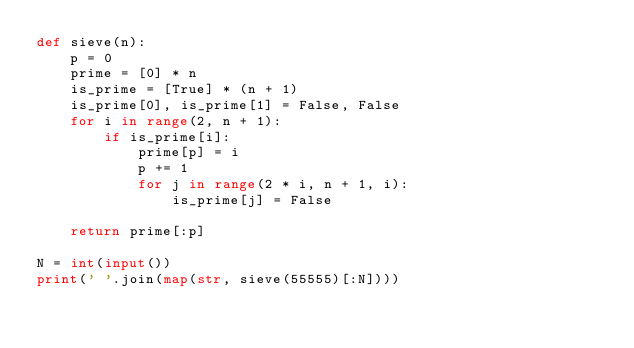<code> <loc_0><loc_0><loc_500><loc_500><_Python_>def sieve(n):
    p = 0
    prime = [0] * n
    is_prime = [True] * (n + 1)
    is_prime[0], is_prime[1] = False, False
    for i in range(2, n + 1):
        if is_prime[i]:
            prime[p] = i
            p += 1
            for j in range(2 * i, n + 1, i):
                is_prime[j] = False
            
    return prime[:p]

N = int(input())
print(' '.join(map(str, sieve(55555)[:N])))</code> 